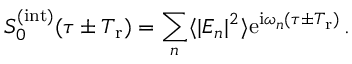Convert formula to latex. <formula><loc_0><loc_0><loc_500><loc_500>S _ { 0 } ^ { ( i n t ) } ( \tau \pm T _ { r } ) = \sum _ { n } \langle | E _ { n } | ^ { 2 } \rangle e ^ { i \omega _ { n } ( \tau \pm T _ { r } ) } \, .</formula> 